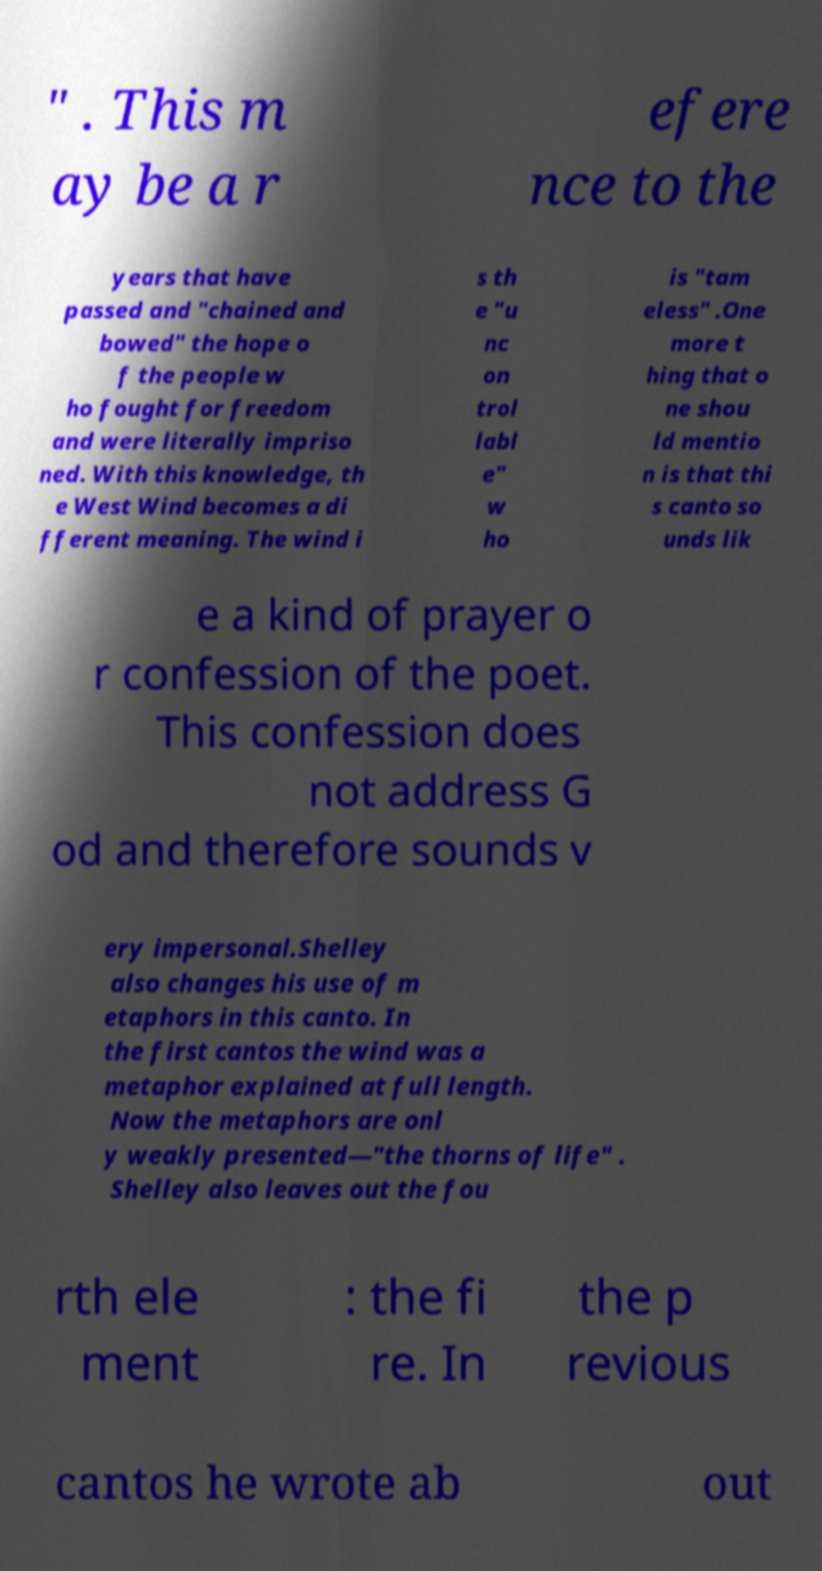Can you read and provide the text displayed in the image?This photo seems to have some interesting text. Can you extract and type it out for me? " . This m ay be a r efere nce to the years that have passed and "chained and bowed" the hope o f the people w ho fought for freedom and were literally impriso ned. With this knowledge, th e West Wind becomes a di fferent meaning. The wind i s th e "u nc on trol labl e" w ho is "tam eless" .One more t hing that o ne shou ld mentio n is that thi s canto so unds lik e a kind of prayer o r confession of the poet. This confession does not address G od and therefore sounds v ery impersonal.Shelley also changes his use of m etaphors in this canto. In the first cantos the wind was a metaphor explained at full length. Now the metaphors are onl y weakly presented—"the thorns of life" . Shelley also leaves out the fou rth ele ment : the fi re. In the p revious cantos he wrote ab out 